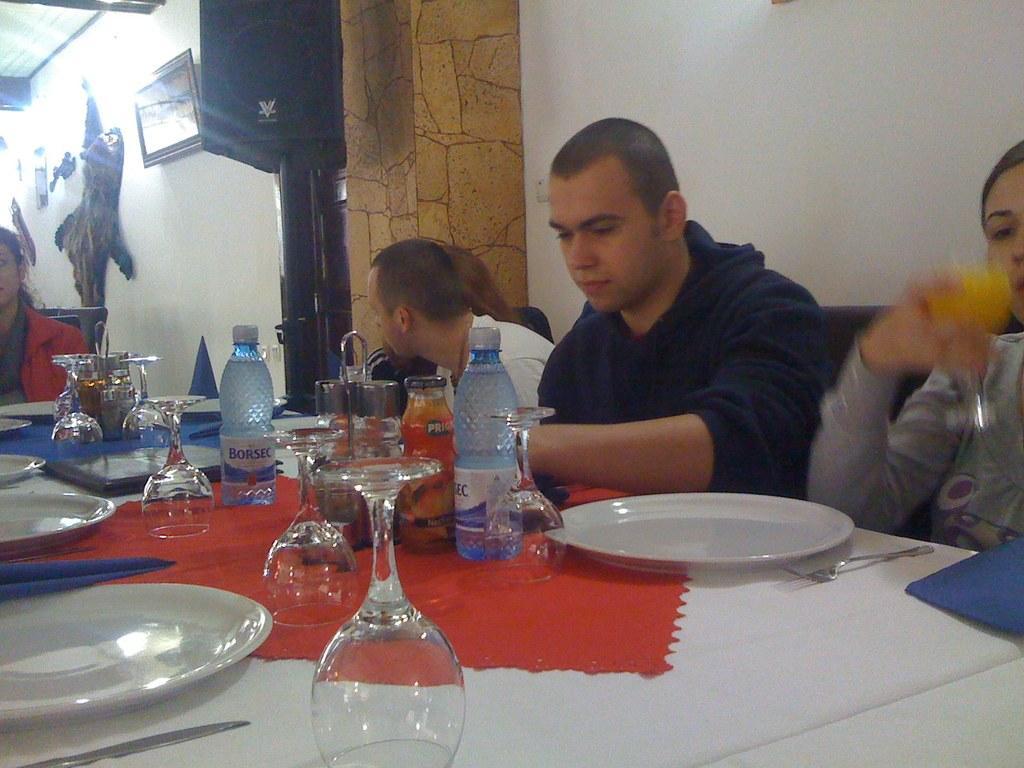How would you summarize this image in a sentence or two? We can see frame and few show pieces on a wall. Here we can see persons sitting on chairs in front of a dining table and on the table we can see water bottles, glasses, plates, forks, table mats and napkins 